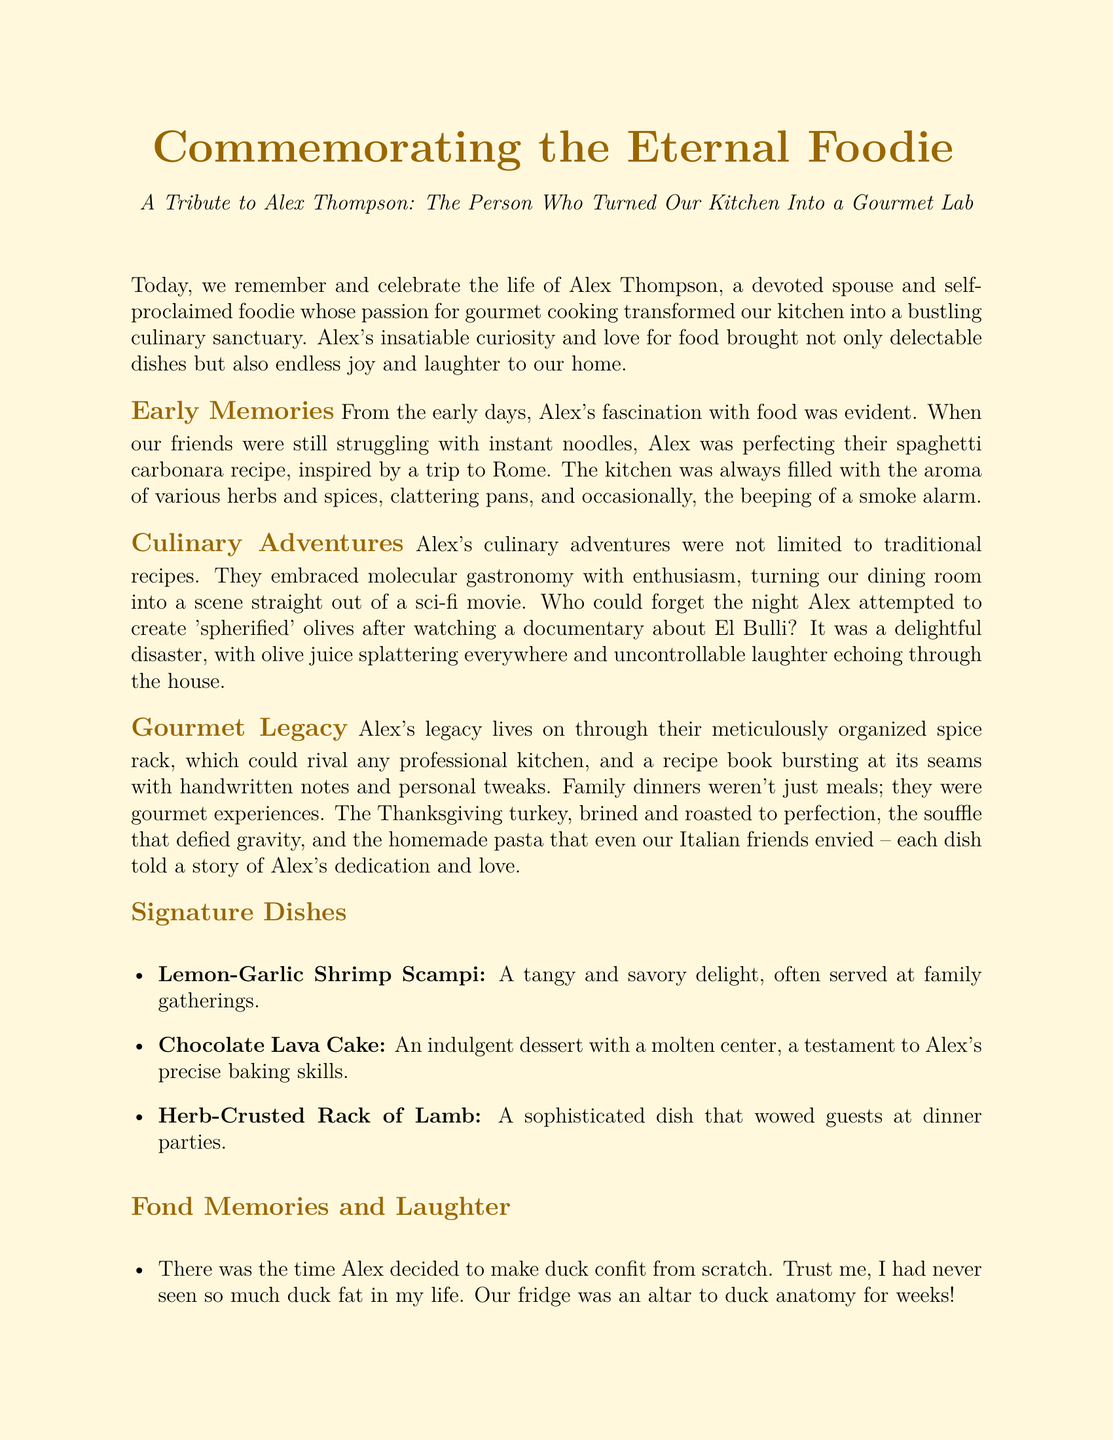What was Alex Thompson's passion? The document states that Alex was a self-proclaimed foodie whose passion for gourmet cooking transformed the kitchen.
Answer: gourmet cooking What did Alex attempt to create inspired by a documentary? The document mentions that Alex attempted to create 'spherified' olives after watching a documentary about El Bulli.
Answer: 'spherified' olives How was the spice rack described? It is stated that Alex's spice rack could rival any professional kitchen.
Answer: rival any professional kitchen What was one of Alex's signature dishes? The document lists several signature dishes, one being Lemon-Garlic Shrimp Scampi.
Answer: Lemon-Garlic Shrimp Scampi What did late-night cravings lead to? The document describes how late-night cravings led to impromptu culinary experiments.
Answer: impromptu culinary experiments What kind of turkey was served at family dinners? The document states the Thanksgiving turkey was brined and roasted to perfection.
Answer: brined and roasted to perfection How did Alex contribute to the home? Alex's love for food brought joy and laughter to the home.
Answer: joy and laughter What did the kitchen represent after Alex's passing? The kitchen stands as a tribute to their inventive spirit and a source of cherished memories.
Answer: tribute to their inventive spirit 